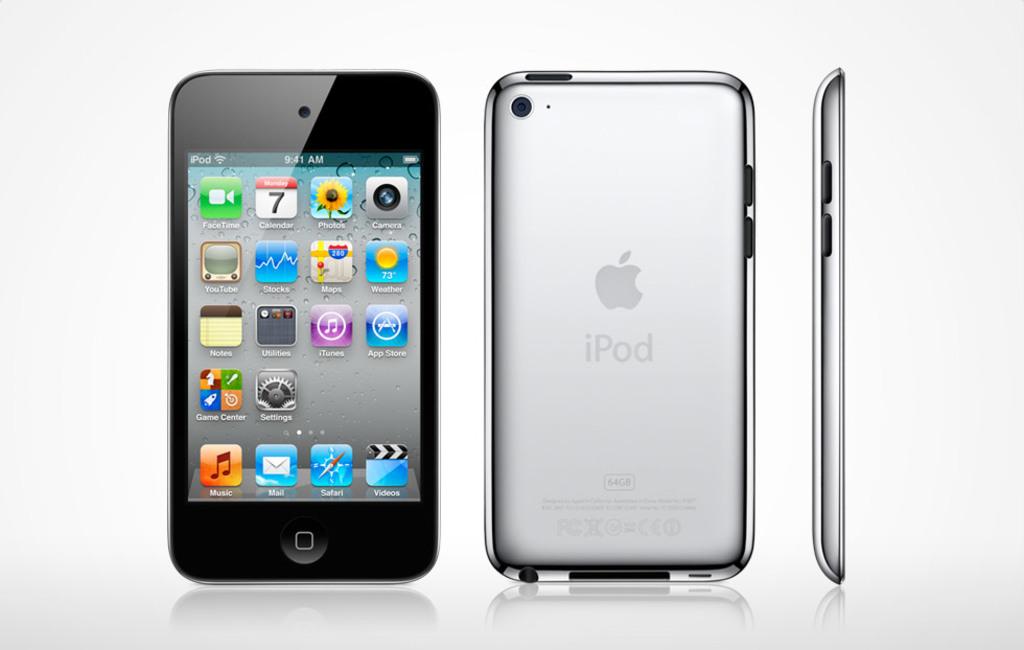What time is shown?
Your response must be concise. 9:41. What is on the back of it?
Provide a succinct answer. Ipod. 